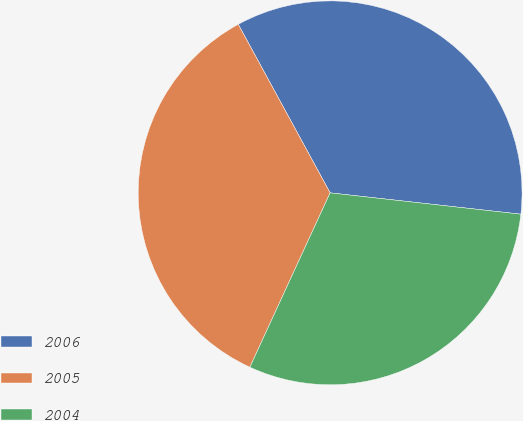Convert chart. <chart><loc_0><loc_0><loc_500><loc_500><pie_chart><fcel>2006<fcel>2005<fcel>2004<nl><fcel>34.72%<fcel>35.19%<fcel>30.09%<nl></chart> 